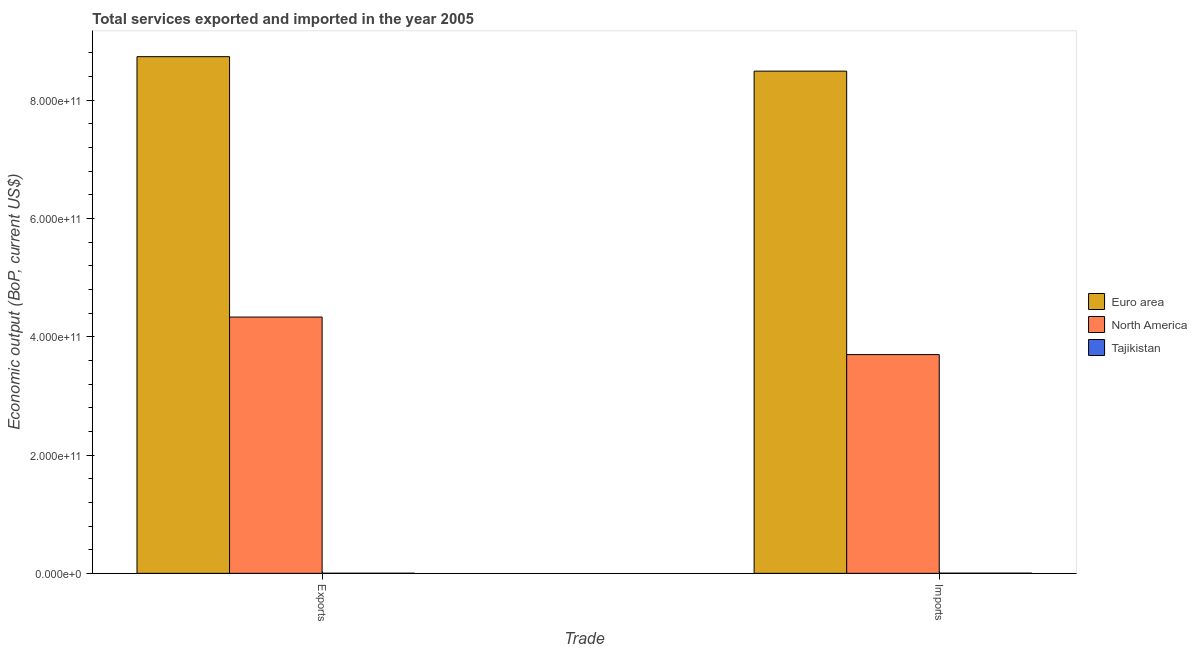How many groups of bars are there?
Your answer should be very brief. 2. Are the number of bars on each tick of the X-axis equal?
Your answer should be compact. Yes. How many bars are there on the 2nd tick from the left?
Offer a very short reply. 3. What is the label of the 2nd group of bars from the left?
Keep it short and to the point. Imports. What is the amount of service imports in Euro area?
Provide a short and direct response. 8.49e+11. Across all countries, what is the maximum amount of service imports?
Your answer should be very brief. 8.49e+11. Across all countries, what is the minimum amount of service imports?
Ensure brevity in your answer.  2.52e+08. In which country was the amount of service imports minimum?
Your answer should be very brief. Tajikistan. What is the total amount of service imports in the graph?
Your response must be concise. 1.22e+12. What is the difference between the amount of service exports in Euro area and that in Tajikistan?
Offer a terse response. 8.73e+11. What is the difference between the amount of service exports in Euro area and the amount of service imports in North America?
Your answer should be compact. 5.04e+11. What is the average amount of service imports per country?
Offer a terse response. 4.06e+11. What is the difference between the amount of service imports and amount of service exports in Tajikistan?
Make the answer very short. 1.05e+08. What is the ratio of the amount of service exports in North America to that in Euro area?
Your response must be concise. 0.5. What does the 2nd bar from the right in Imports represents?
Offer a very short reply. North America. Are all the bars in the graph horizontal?
Offer a terse response. No. How many countries are there in the graph?
Give a very brief answer. 3. What is the difference between two consecutive major ticks on the Y-axis?
Ensure brevity in your answer.  2.00e+11. Does the graph contain any zero values?
Provide a succinct answer. No. Does the graph contain grids?
Your answer should be compact. No. Where does the legend appear in the graph?
Ensure brevity in your answer.  Center right. How many legend labels are there?
Keep it short and to the point. 3. How are the legend labels stacked?
Offer a very short reply. Vertical. What is the title of the graph?
Provide a succinct answer. Total services exported and imported in the year 2005. What is the label or title of the X-axis?
Your response must be concise. Trade. What is the label or title of the Y-axis?
Your response must be concise. Economic output (BoP, current US$). What is the Economic output (BoP, current US$) in Euro area in Exports?
Provide a short and direct response. 8.74e+11. What is the Economic output (BoP, current US$) of North America in Exports?
Offer a very short reply. 4.33e+11. What is the Economic output (BoP, current US$) in Tajikistan in Exports?
Keep it short and to the point. 1.46e+08. What is the Economic output (BoP, current US$) in Euro area in Imports?
Ensure brevity in your answer.  8.49e+11. What is the Economic output (BoP, current US$) of North America in Imports?
Your answer should be compact. 3.70e+11. What is the Economic output (BoP, current US$) of Tajikistan in Imports?
Ensure brevity in your answer.  2.52e+08. Across all Trade, what is the maximum Economic output (BoP, current US$) of Euro area?
Your answer should be very brief. 8.74e+11. Across all Trade, what is the maximum Economic output (BoP, current US$) in North America?
Ensure brevity in your answer.  4.33e+11. Across all Trade, what is the maximum Economic output (BoP, current US$) in Tajikistan?
Keep it short and to the point. 2.52e+08. Across all Trade, what is the minimum Economic output (BoP, current US$) of Euro area?
Offer a terse response. 8.49e+11. Across all Trade, what is the minimum Economic output (BoP, current US$) of North America?
Provide a succinct answer. 3.70e+11. Across all Trade, what is the minimum Economic output (BoP, current US$) in Tajikistan?
Make the answer very short. 1.46e+08. What is the total Economic output (BoP, current US$) of Euro area in the graph?
Give a very brief answer. 1.72e+12. What is the total Economic output (BoP, current US$) in North America in the graph?
Your response must be concise. 8.03e+11. What is the total Economic output (BoP, current US$) of Tajikistan in the graph?
Your response must be concise. 3.98e+08. What is the difference between the Economic output (BoP, current US$) of Euro area in Exports and that in Imports?
Give a very brief answer. 2.45e+1. What is the difference between the Economic output (BoP, current US$) in North America in Exports and that in Imports?
Your answer should be compact. 6.35e+1. What is the difference between the Economic output (BoP, current US$) of Tajikistan in Exports and that in Imports?
Your answer should be very brief. -1.05e+08. What is the difference between the Economic output (BoP, current US$) of Euro area in Exports and the Economic output (BoP, current US$) of North America in Imports?
Ensure brevity in your answer.  5.04e+11. What is the difference between the Economic output (BoP, current US$) of Euro area in Exports and the Economic output (BoP, current US$) of Tajikistan in Imports?
Keep it short and to the point. 8.73e+11. What is the difference between the Economic output (BoP, current US$) of North America in Exports and the Economic output (BoP, current US$) of Tajikistan in Imports?
Give a very brief answer. 4.33e+11. What is the average Economic output (BoP, current US$) in Euro area per Trade?
Your response must be concise. 8.61e+11. What is the average Economic output (BoP, current US$) of North America per Trade?
Provide a short and direct response. 4.02e+11. What is the average Economic output (BoP, current US$) of Tajikistan per Trade?
Provide a succinct answer. 1.99e+08. What is the difference between the Economic output (BoP, current US$) in Euro area and Economic output (BoP, current US$) in North America in Exports?
Your answer should be very brief. 4.40e+11. What is the difference between the Economic output (BoP, current US$) of Euro area and Economic output (BoP, current US$) of Tajikistan in Exports?
Keep it short and to the point. 8.73e+11. What is the difference between the Economic output (BoP, current US$) in North America and Economic output (BoP, current US$) in Tajikistan in Exports?
Keep it short and to the point. 4.33e+11. What is the difference between the Economic output (BoP, current US$) in Euro area and Economic output (BoP, current US$) in North America in Imports?
Your response must be concise. 4.79e+11. What is the difference between the Economic output (BoP, current US$) of Euro area and Economic output (BoP, current US$) of Tajikistan in Imports?
Offer a very short reply. 8.49e+11. What is the difference between the Economic output (BoP, current US$) in North America and Economic output (BoP, current US$) in Tajikistan in Imports?
Your response must be concise. 3.70e+11. What is the ratio of the Economic output (BoP, current US$) of Euro area in Exports to that in Imports?
Your answer should be very brief. 1.03. What is the ratio of the Economic output (BoP, current US$) of North America in Exports to that in Imports?
Offer a terse response. 1.17. What is the ratio of the Economic output (BoP, current US$) of Tajikistan in Exports to that in Imports?
Provide a short and direct response. 0.58. What is the difference between the highest and the second highest Economic output (BoP, current US$) of Euro area?
Your answer should be very brief. 2.45e+1. What is the difference between the highest and the second highest Economic output (BoP, current US$) of North America?
Provide a succinct answer. 6.35e+1. What is the difference between the highest and the second highest Economic output (BoP, current US$) of Tajikistan?
Offer a terse response. 1.05e+08. What is the difference between the highest and the lowest Economic output (BoP, current US$) of Euro area?
Provide a succinct answer. 2.45e+1. What is the difference between the highest and the lowest Economic output (BoP, current US$) in North America?
Ensure brevity in your answer.  6.35e+1. What is the difference between the highest and the lowest Economic output (BoP, current US$) in Tajikistan?
Ensure brevity in your answer.  1.05e+08. 